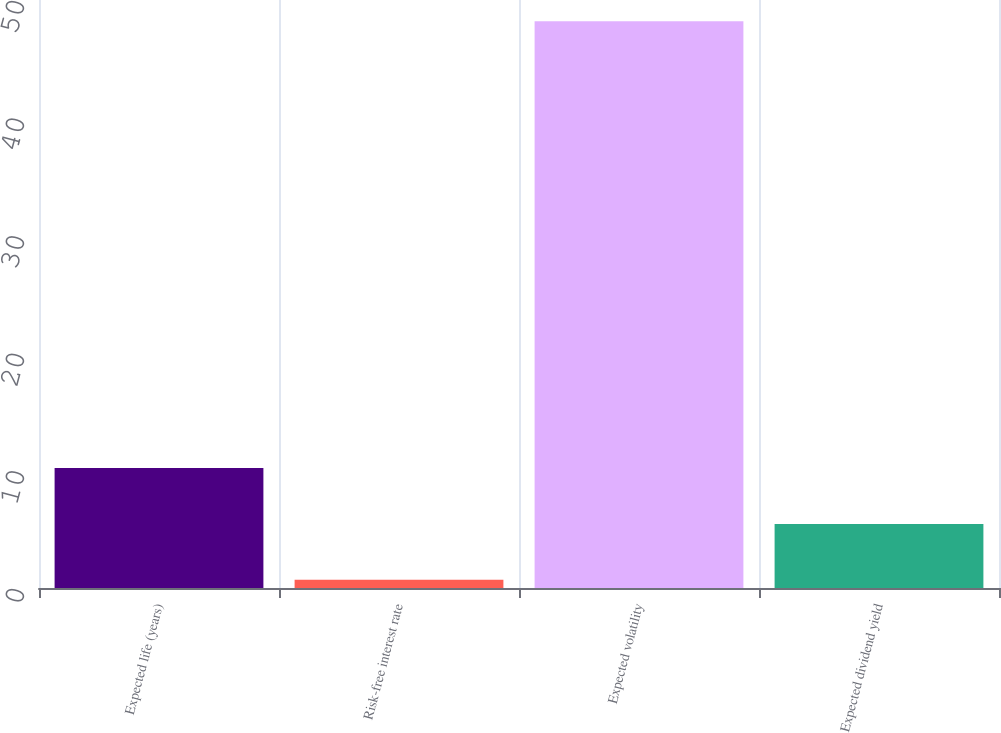<chart> <loc_0><loc_0><loc_500><loc_500><bar_chart><fcel>Expected life (years)<fcel>Risk-free interest rate<fcel>Expected volatility<fcel>Expected dividend yield<nl><fcel>10.2<fcel>0.7<fcel>48.2<fcel>5.45<nl></chart> 